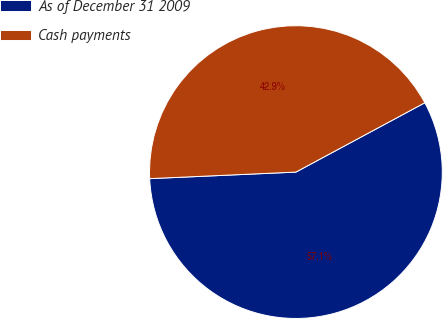<chart> <loc_0><loc_0><loc_500><loc_500><pie_chart><fcel>As of December 31 2009<fcel>Cash payments<nl><fcel>57.14%<fcel>42.86%<nl></chart> 